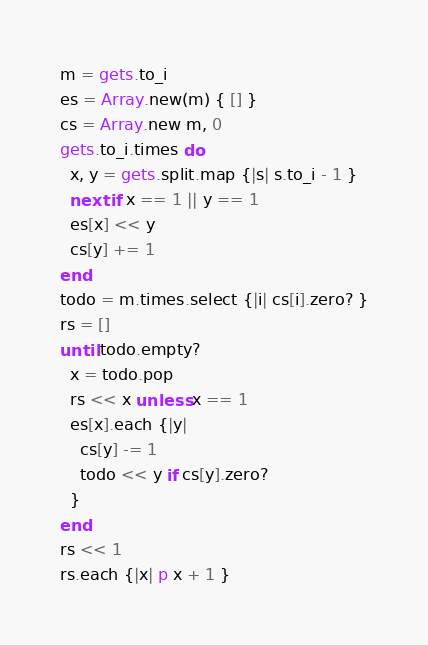Convert code to text. <code><loc_0><loc_0><loc_500><loc_500><_Ruby_>m = gets.to_i
es = Array.new(m) { [] }
cs = Array.new m, 0
gets.to_i.times do
  x, y = gets.split.map {|s| s.to_i - 1 }
  next if x == 1 || y == 1
  es[x] << y
  cs[y] += 1
end
todo = m.times.select {|i| cs[i].zero? }
rs = []
until todo.empty?
  x = todo.pop
  rs << x unless x == 1
  es[x].each {|y|
    cs[y] -= 1
    todo << y if cs[y].zero?
  }
end
rs << 1
rs.each {|x| p x + 1 }</code> 